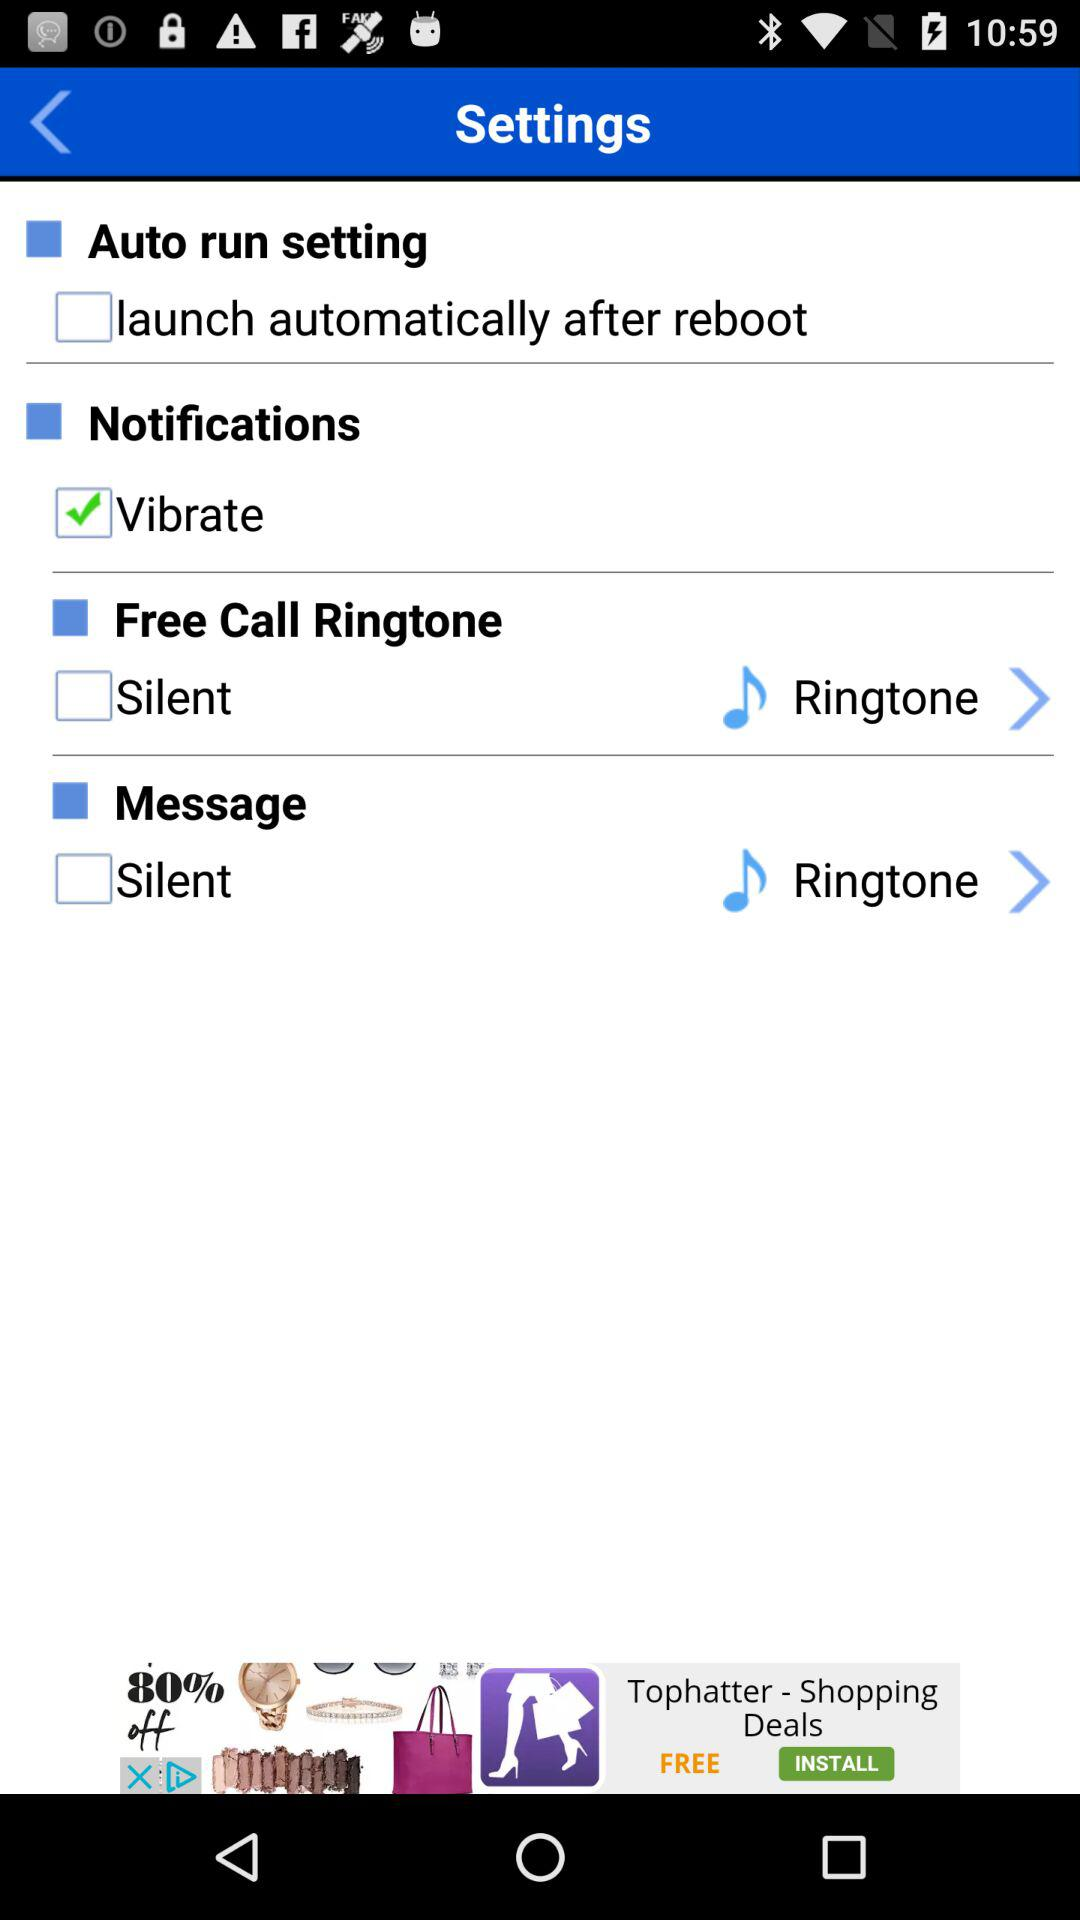What is the given email address? The given email address is appcrawler1@gmail.com. 